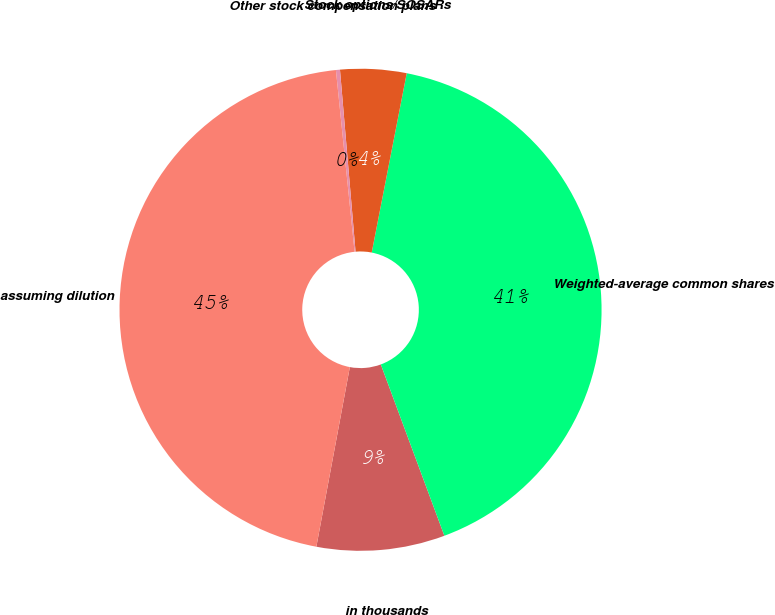Convert chart to OTSL. <chart><loc_0><loc_0><loc_500><loc_500><pie_chart><fcel>in thousands<fcel>Weighted-average common shares<fcel>Stock options/SOSARs<fcel>Other stock compensation plans<fcel>assuming dilution<nl><fcel>8.59%<fcel>41.28%<fcel>4.43%<fcel>0.27%<fcel>45.44%<nl></chart> 